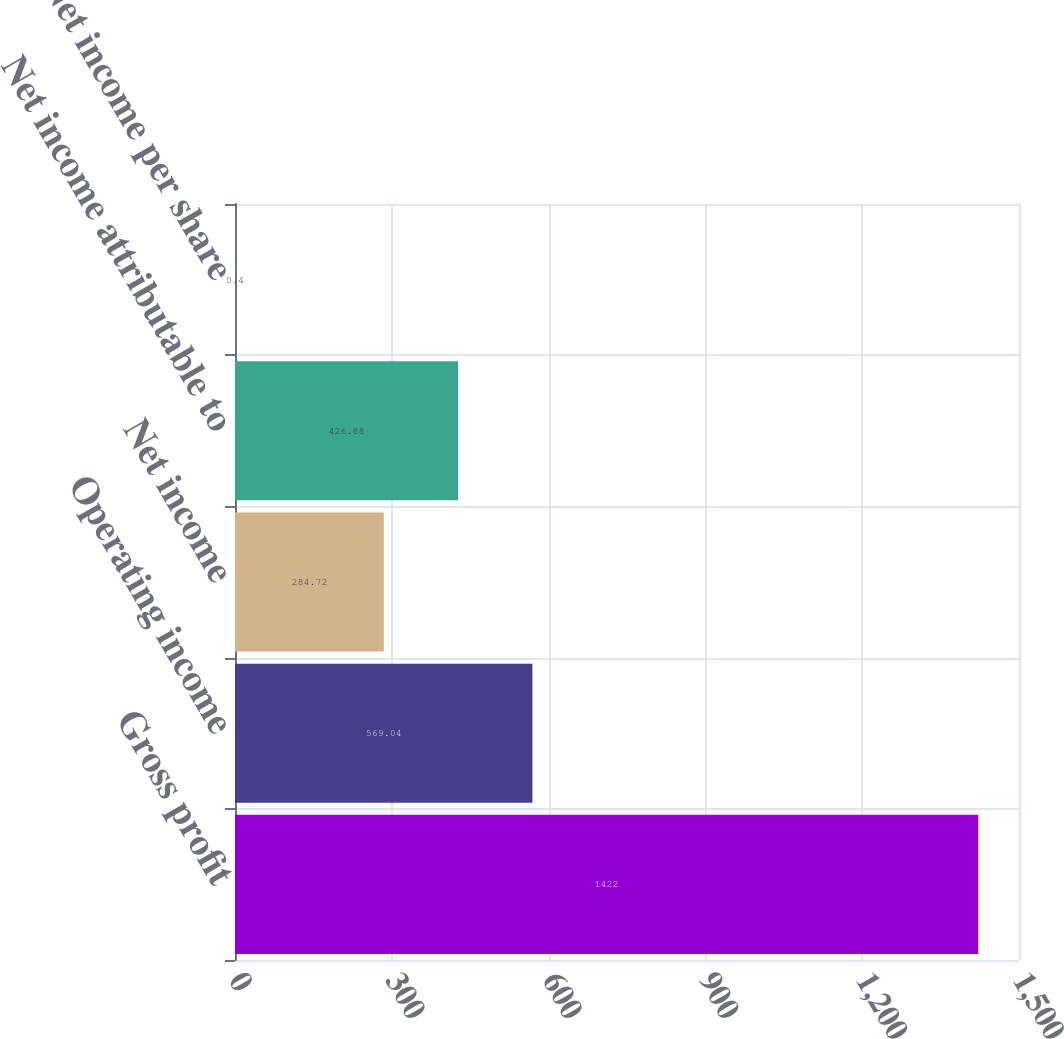Convert chart to OTSL. <chart><loc_0><loc_0><loc_500><loc_500><bar_chart><fcel>Gross profit<fcel>Operating income<fcel>Net income<fcel>Net income attributable to<fcel>Net income per share<nl><fcel>1422<fcel>569.04<fcel>284.72<fcel>426.88<fcel>0.4<nl></chart> 